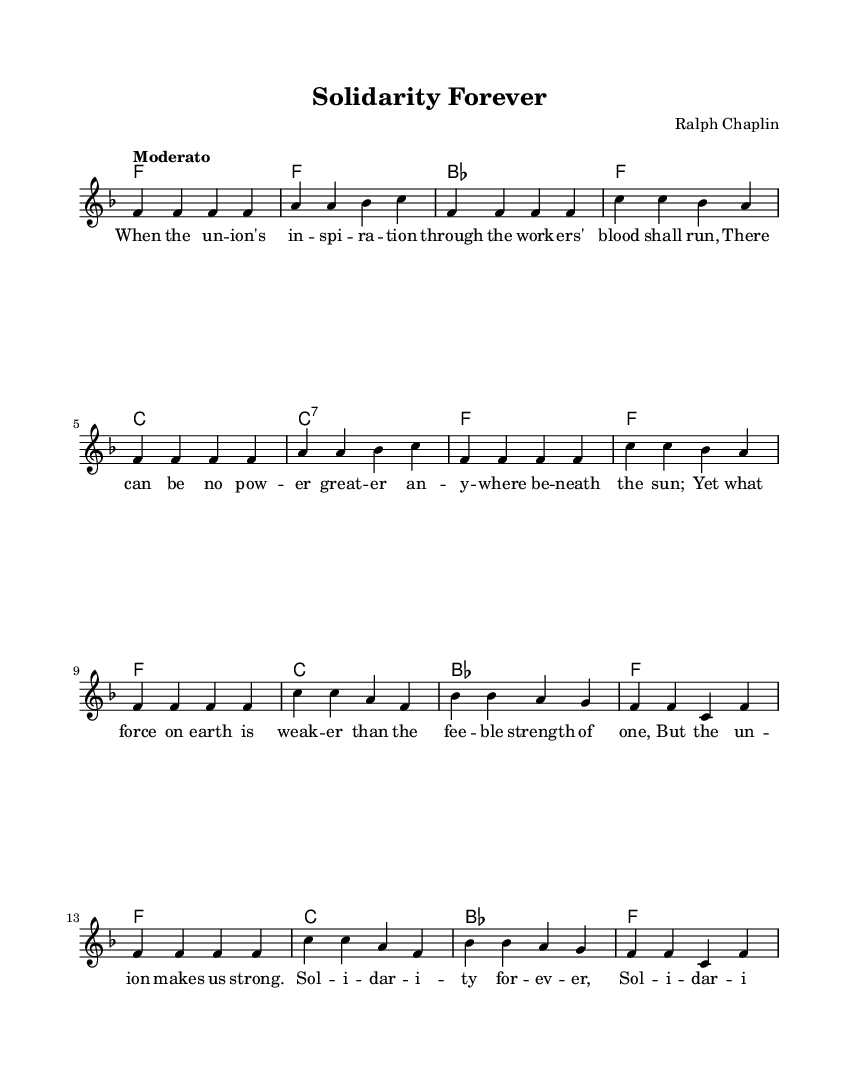What is the key signature of this music? The key signature is indicated at the beginning of the sheet music. It notes one flat, which corresponds to the key of F major.
Answer: F major What is the time signature of the piece? The time signature is shown at the beginning of the sheet music, represented as 4/4. This indicates there are four beats per measure and the quarter note receives one beat.
Answer: 4/4 What is the tempo marking for the piece? The tempo marking is located above the staff and is indicated as "Moderato," which suggests a moderate speed.
Answer: Moderato How many measures are in the verse section of the song? The verse consists of two identical sections, with four measures each, totaling eight measures. To determine this, one counts the measures as notated for the verse lyrics.
Answer: 8 What is the first lyric of the chorus? The lyrics of the chorus start with "Solidarity forever," as indicated beneath the melody notes in the sheet music. This is the first line after the verse section.
Answer: Solidarity forever How do the harmony chords repeat during the chorus? By examining the harmonic structure of the piece, it's evident that the chords in the chorus repeat the same order as those in the verse, maintaining the same rhythmic pattern throughout.
Answer: Same as verse What is the emotional theme represented in this piece? The title "Solidarity Forever" indicates a theme centered around unity and strength among workers, which is characteristic of labor movement protest songs from the 1960s. This thematic concept is reinforced by the lyrics and overall structure of the music.
Answer: Unity 